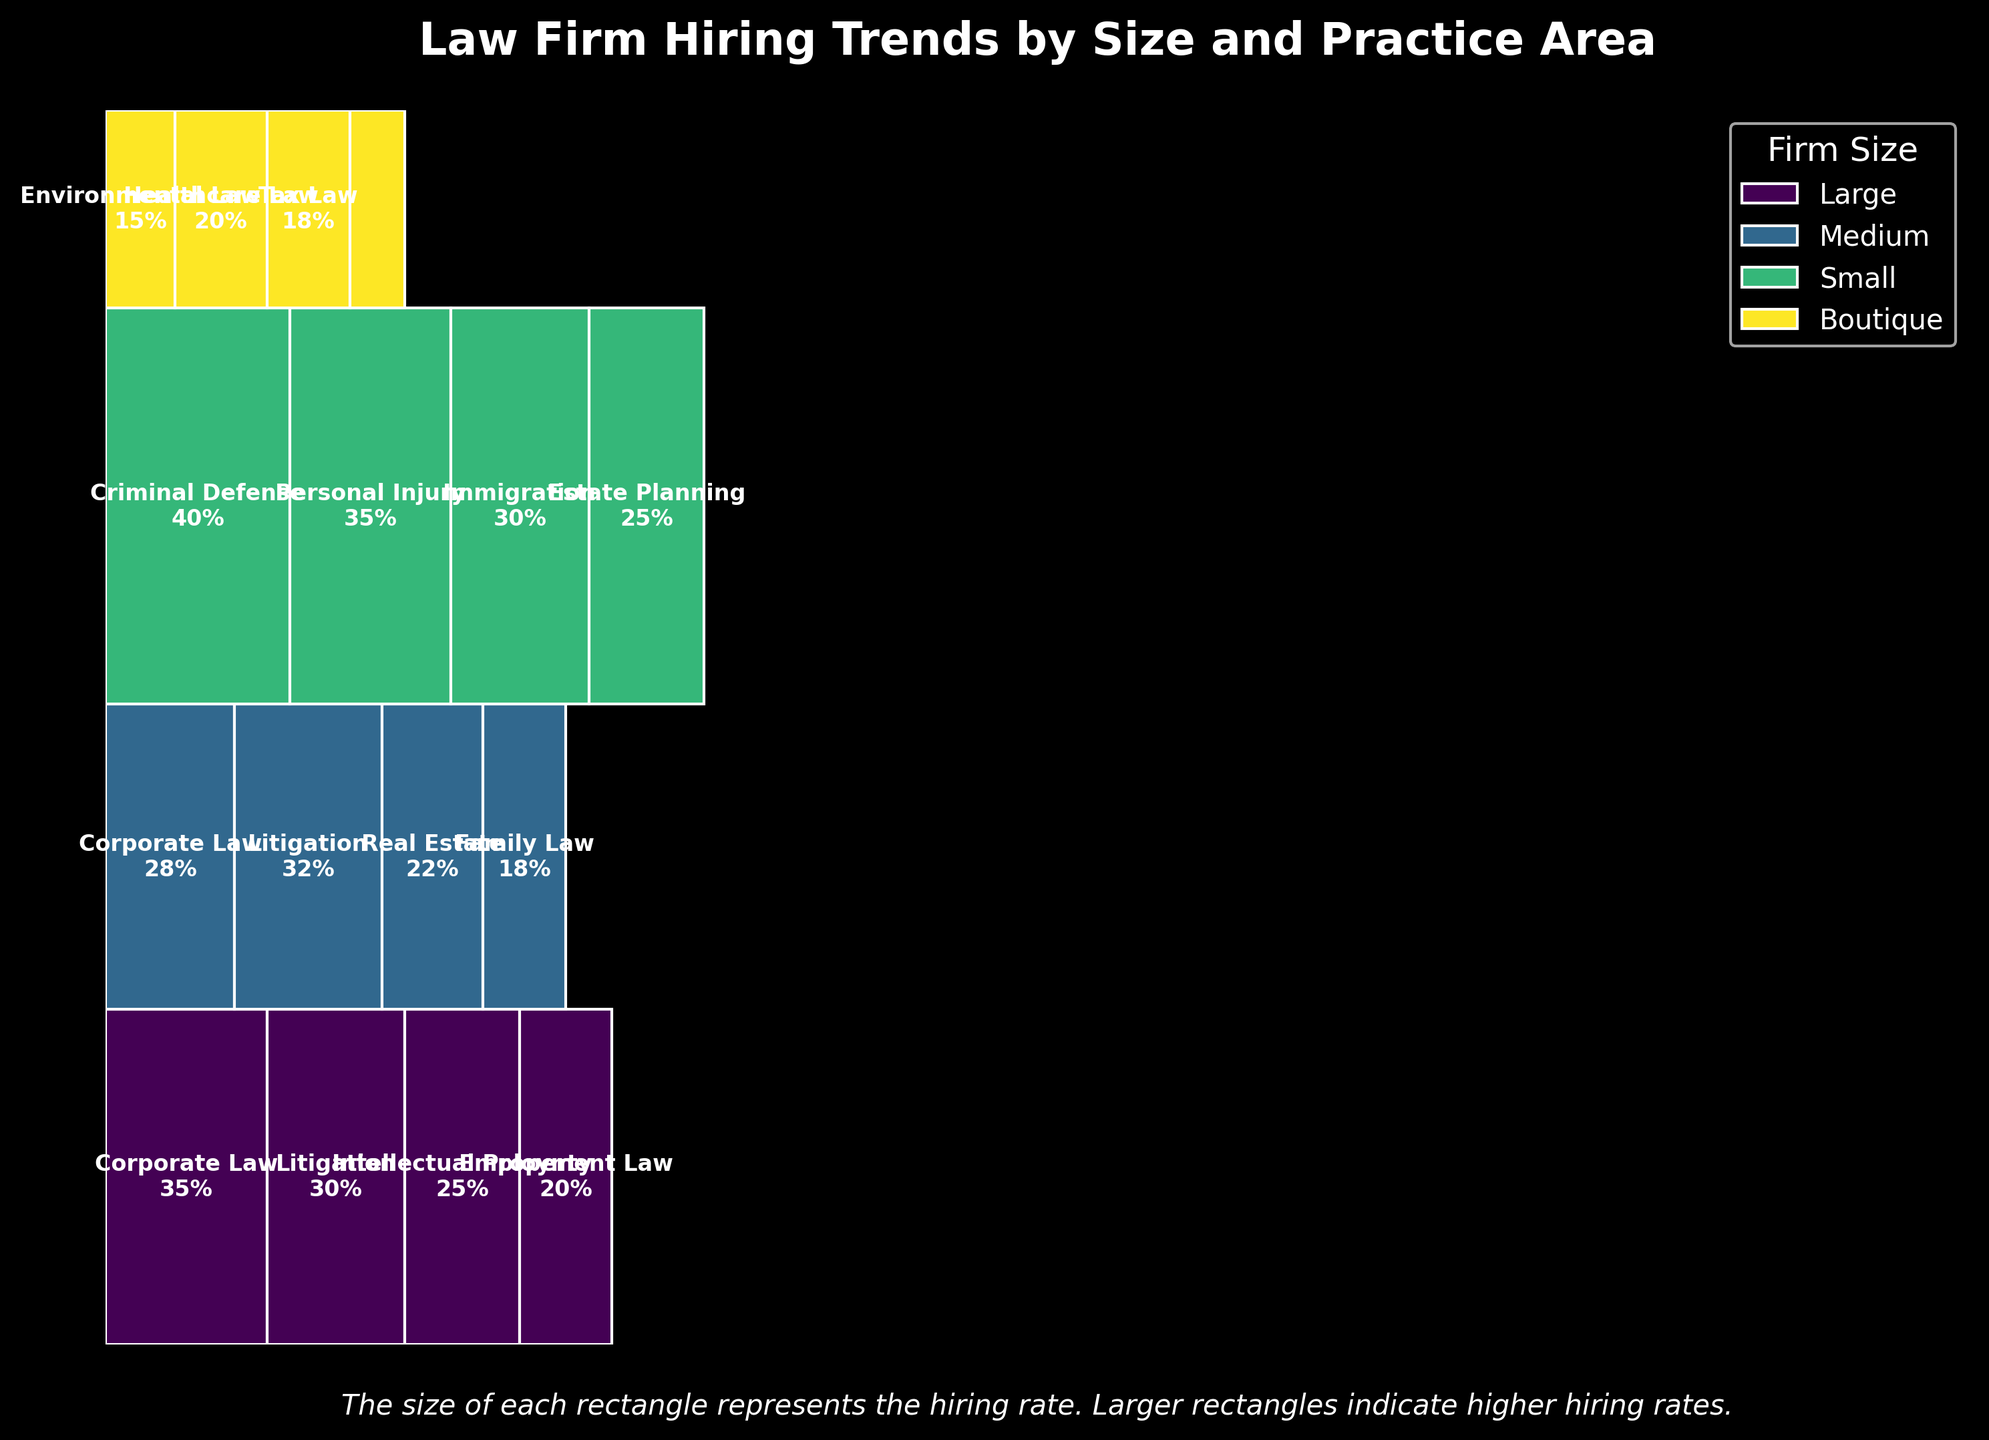What is the total hiring rate percentage for large firms? Add up the hiring rates for all practice areas in large firms: 35% (Corporate Law) + 30% (Litigation) + 25% (Intellectual Property) + 20% (Employment Law) = 110%.
Answer: 110% Which firm size has the highest hiring rate in Criminal Defense? Look for the firm size associated with Criminal Defense. Only small firms have a hiring rate of 40% for Criminal Defense, which is also the highest.
Answer: Small How does the hiring rate for boutique firms in Healthcare Law compare to medium firms in Family Law? Boutique firms have a hiring rate of 20% in Healthcare Law, while medium firms have an 18% hiring rate in Family Law. So, 20% (boutique) is greater than 18% (medium).
Answer: Boutique firms' rate is higher Which practice area in large firms has the lowest hiring rate, and what is it? Among large firms, the hiring rates are 35% (Corporate Law), 30% (Litigation), 25% (Intellectual Property), and 20% (Employment Law). Employment Law is the lowest with 20%.
Answer: Employment Law, 20% What is the sum of the hiring rates for medium firms across all practice areas? Include hiring rates for all medium firm practice areas: 28% (Corporate Law) + 32% (Litigation) + 22% (Real Estate) + 18% (Family Law) = 100%.
Answer: 100% Is the hiring rate for Estate Planning higher or lower than for Environmental Law? Estate Planning (Small firms) has a hiring rate of 25%, while Environmental Law (Boutique firms) has a rate of 15%. Therefore, Estate Planning's rate is higher.
Answer: Higher What total percentage of hires do small firms contribute to the overall plot? Add the hiring rates for all practice areas under small firms: 40% (Criminal Defense) + 35% (Personal Injury) + 30% (Immigration) + 25% (Estate Planning) = 130%.
Answer: 130% Compare the hiring rate for Corporate Law in large firms to that in medium firms. Large firms have a 35% hiring rate in Corporate Law, while medium firms have a 28% rate. Therefore, large firms have a higher rate.
Answer: Large firms' rate is higher What is the total percentage of hires for boutique firms in all their practice areas? Add up the hiring rates for all practice areas under boutique firms: 15% (Environmental Law) + 20% (Healthcare Law) + 18% (Tax Law) + 12% (Cybersecurity Law) = 65%.
Answer: 65% Which firm size has the most diverse range of practice areas? By looking at the number of different practice areas for each firm size:
- Large firms: 4 areas (Corporate Law, Litigation, Intellectual Property, Employment Law)
- Medium firms: 4 areas (Corporate Law, Litigation, Real Estate, Family Law)
- Small firms: 4 areas (Criminal Defense, Personal Injury, Immigration, Estate Planning)
- Boutique firms: 4 areas (Environmental Law, Healthcare Law, Tax Law, Cybersecurity Law)
All firm sizes offer practice areas equally diverse.
Answer: All firm sizes 